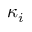Convert formula to latex. <formula><loc_0><loc_0><loc_500><loc_500>\kappa _ { i }</formula> 